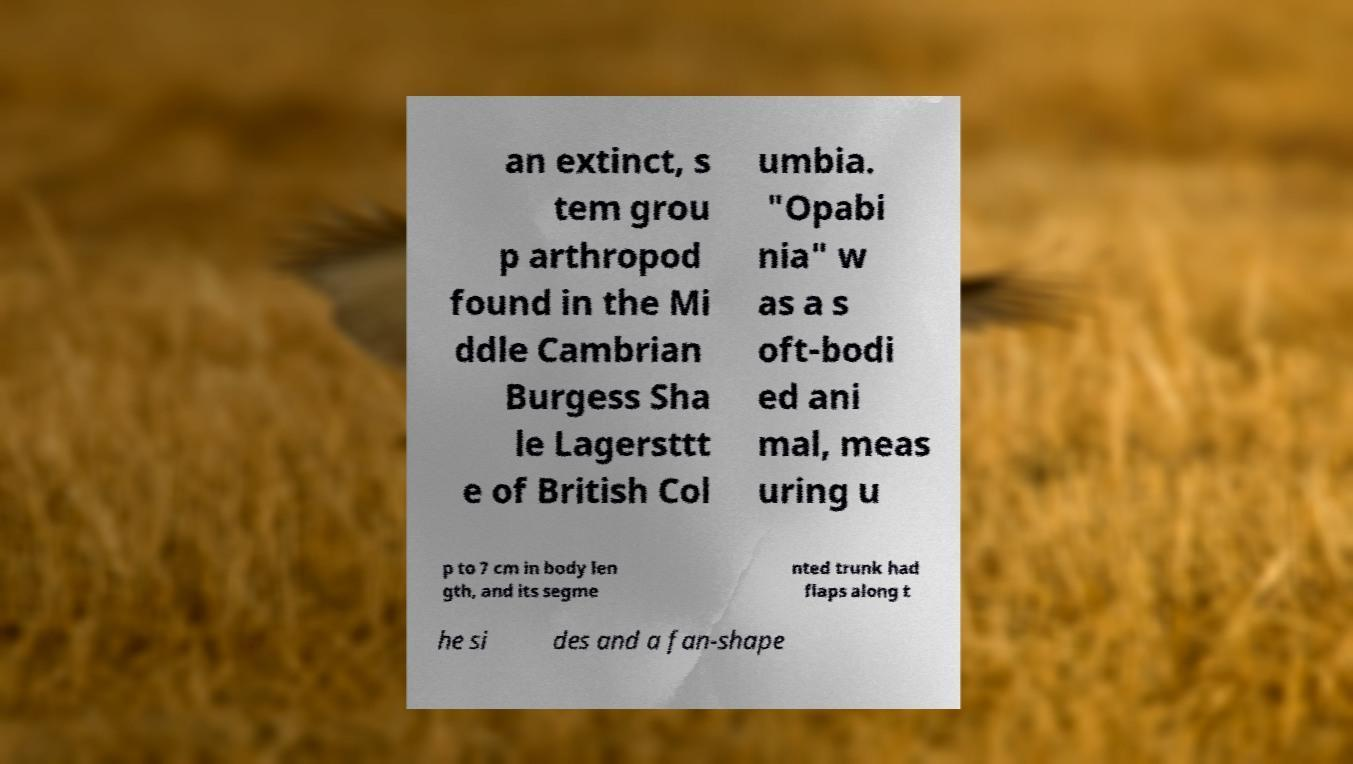What messages or text are displayed in this image? I need them in a readable, typed format. an extinct, s tem grou p arthropod found in the Mi ddle Cambrian Burgess Sha le Lagersttt e of British Col umbia. "Opabi nia" w as a s oft-bodi ed ani mal, meas uring u p to 7 cm in body len gth, and its segme nted trunk had flaps along t he si des and a fan-shape 